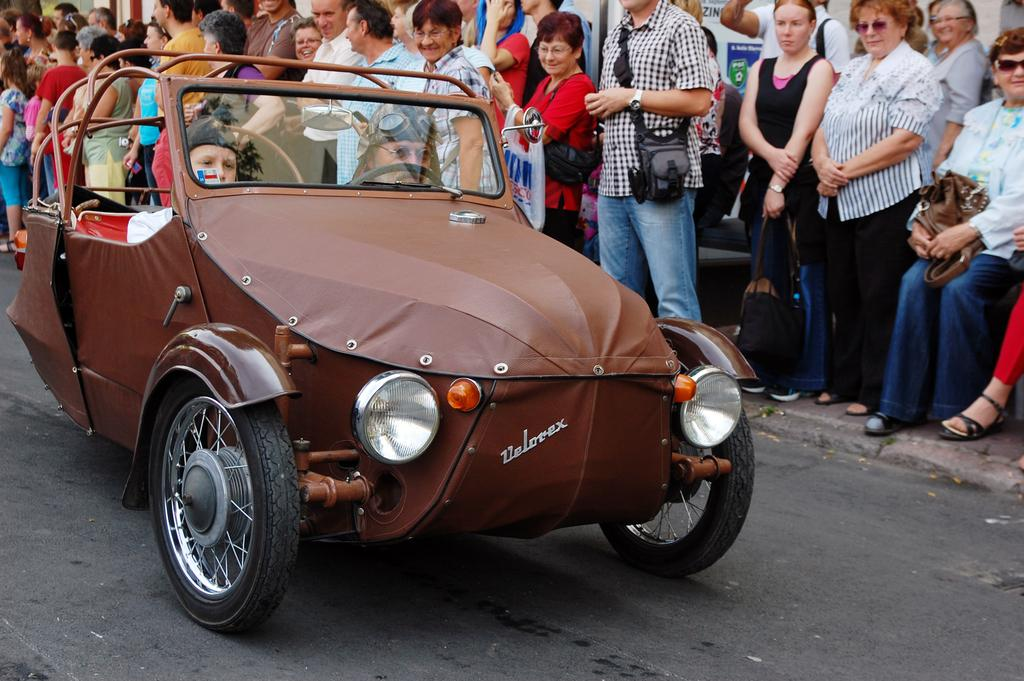What is the main feature of the image? There is a road in the image. What are the people on the road doing? People are riding vehicles on the road. Are there any spectators in the image? Yes, there are people watching the vehicle riders. What type of needle is being used to sew the pie in the image? There is no needle or pie present in the image; it features a road with people riding vehicles and spectators watching. 